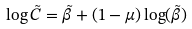<formula> <loc_0><loc_0><loc_500><loc_500>\log \tilde { C } = \tilde { \beta } + ( 1 - \mu ) \log ( \tilde { \beta } )</formula> 